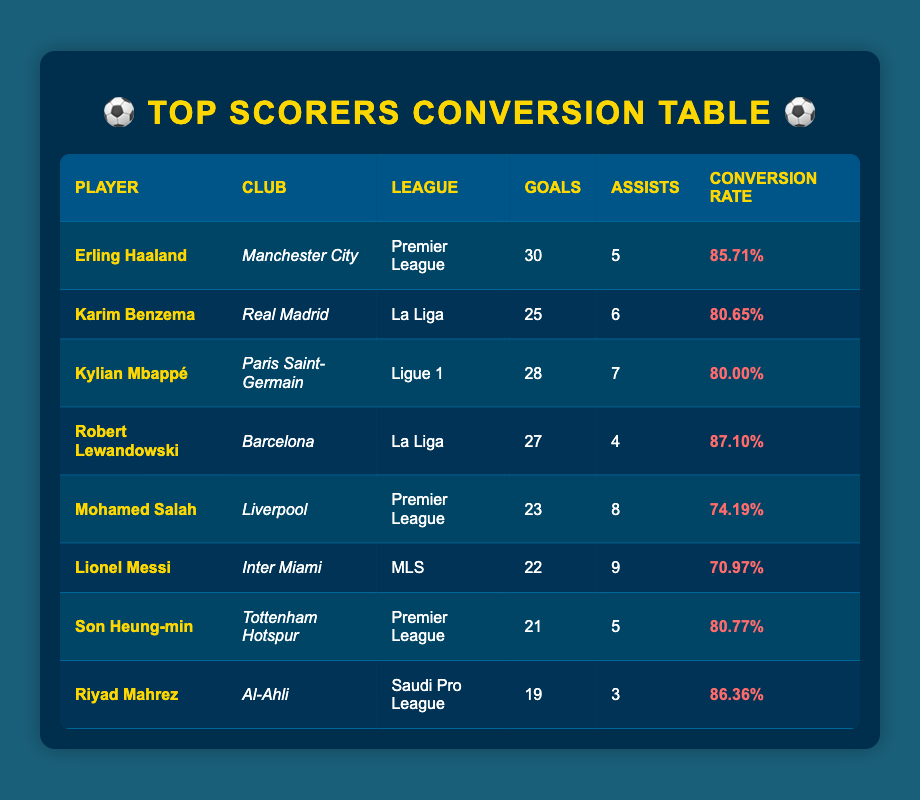What is the highest number of goals scored by a player? The highest number of goals scored by a player is found by looking for the maximum in the "Goals" column. Erling Haaland has scored 30 goals, which is the highest value in the table.
Answer: 30 Which player has the most assists? To find the player with the most assists, we need to compare the values in the "Assists" column. Lionel Messi has 9 assists, which is the highest in that column.
Answer: 9 Is Kylian Mbappé's conversion rate higher than 80%? To verify this, we check Kylian Mbappé's conversion rate in the "Conversion Rate" column, which is 80.00%. Since 80.00% is equal to 80%, the answer is yes.
Answer: Yes What is the total number of goals scored by players from the Premier League? We sum the goals scored by players in the Premier League: Haaland (30) + Mohamed Salah (23) + Son Heung-min (21) = 74.
Answer: 74 Which league has a player with the highest goals-to-assists ratio? First, we calculate the goals-to-assists ratio for each player. Erling Haaland's ratio is 30/5=6.0, Karim Benzema's is 25/6=4.17, Kylian Mbappé's is 28/7=4.0, and so forth. The highest ratio is 6.0 for Erling Haaland in the Premier League.
Answer: Premier League How many players scored more than 25 goals? We filter through the "Goals" column and count players who scored more than 25 goals. The players are Erling Haaland (30), Karim Benzema (25), Kylian Mbappé (28), and Robert Lewandowski (27), making a total of 4 players.
Answer: 4 What is the difference in conversion rates between Haaland and Salah? To find this, we subtract Salah's conversion rate (74.19%) from Haaland's (85.71%). The difference is 85.71% - 74.19% = 11.52%.
Answer: 11.52% Has any player scored more than 22 goals and made fewer than 5 assists? We examine the data for players with more than 22 goals. Both Robert Lewandowski (27 goals, 4 assists) and Lionel Messi (22 goals, 9 assists) are candidates. Lewandowski fits the criteria.
Answer: Yes 